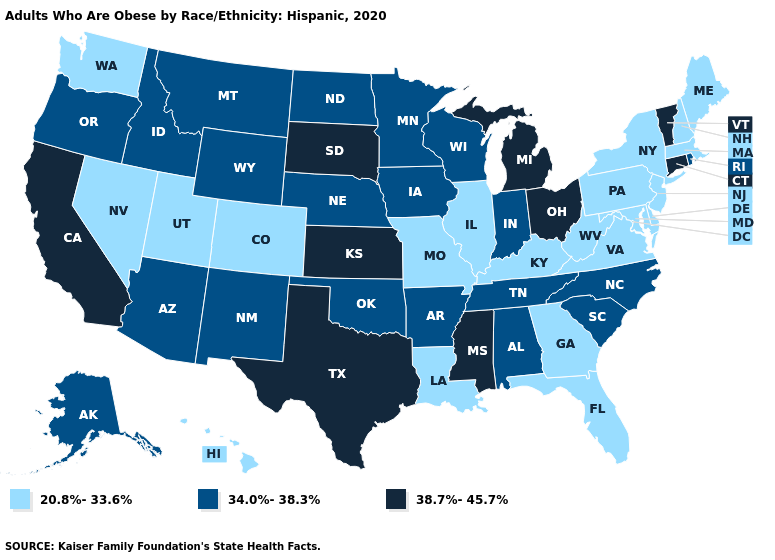Name the states that have a value in the range 34.0%-38.3%?
Give a very brief answer. Alabama, Alaska, Arizona, Arkansas, Idaho, Indiana, Iowa, Minnesota, Montana, Nebraska, New Mexico, North Carolina, North Dakota, Oklahoma, Oregon, Rhode Island, South Carolina, Tennessee, Wisconsin, Wyoming. Name the states that have a value in the range 20.8%-33.6%?
Be succinct. Colorado, Delaware, Florida, Georgia, Hawaii, Illinois, Kentucky, Louisiana, Maine, Maryland, Massachusetts, Missouri, Nevada, New Hampshire, New Jersey, New York, Pennsylvania, Utah, Virginia, Washington, West Virginia. Among the states that border New York , does New Jersey have the highest value?
Keep it brief. No. Does Virginia have a lower value than West Virginia?
Be succinct. No. Does the first symbol in the legend represent the smallest category?
Keep it brief. Yes. Among the states that border North Dakota , does Montana have the lowest value?
Concise answer only. Yes. Does Mississippi have the highest value in the USA?
Keep it brief. Yes. Does Pennsylvania have a higher value than Virginia?
Write a very short answer. No. Does the first symbol in the legend represent the smallest category?
Answer briefly. Yes. Does North Dakota have the highest value in the USA?
Be succinct. No. What is the value of New Mexico?
Write a very short answer. 34.0%-38.3%. What is the highest value in states that border Minnesota?
Quick response, please. 38.7%-45.7%. Is the legend a continuous bar?
Be succinct. No. Name the states that have a value in the range 38.7%-45.7%?
Be succinct. California, Connecticut, Kansas, Michigan, Mississippi, Ohio, South Dakota, Texas, Vermont. 